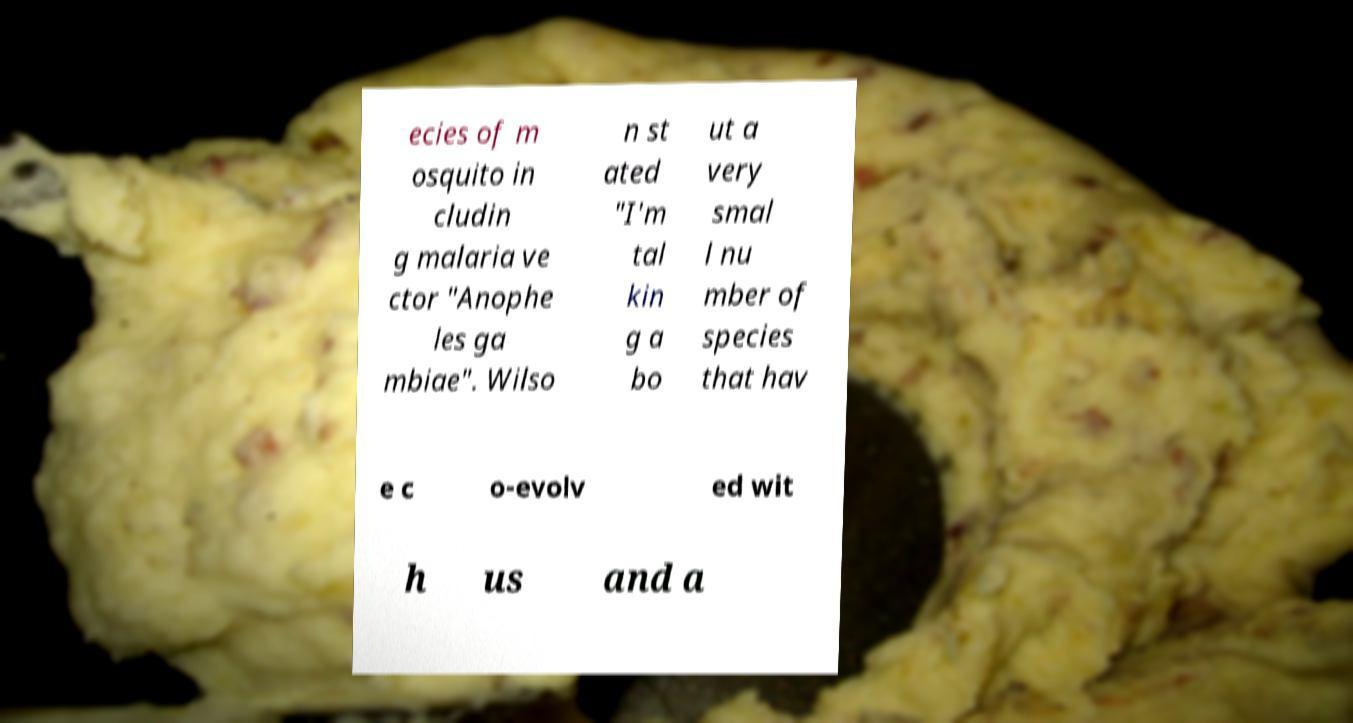Could you extract and type out the text from this image? ecies of m osquito in cludin g malaria ve ctor "Anophe les ga mbiae". Wilso n st ated "I'm tal kin g a bo ut a very smal l nu mber of species that hav e c o-evolv ed wit h us and a 